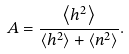Convert formula to latex. <formula><loc_0><loc_0><loc_500><loc_500>A = \frac { \left \langle h ^ { 2 } \right \rangle } { \left \langle h ^ { 2 } \right \rangle + \left \langle n ^ { 2 } \right \rangle } .</formula> 